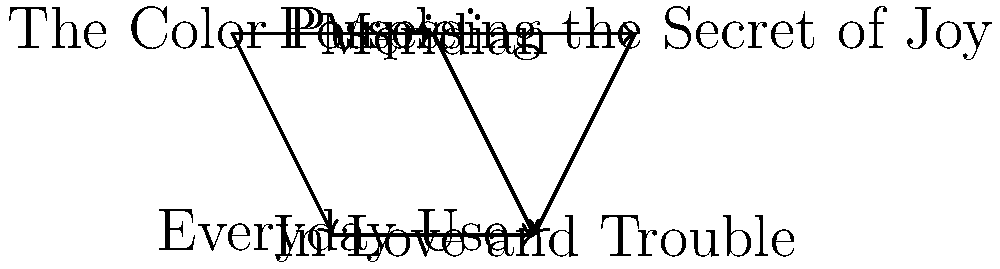In the directed graph representing the flow of themes across Alice Walker's works, which book appears to be the most influential, serving as a source for multiple other works? To determine the most influential book in Alice Walker's works based on the given directed graph, we need to follow these steps:

1. Identify the nodes (books) in the graph:
   - The Color Purple
   - Meridian
   - Possessing the Secret of Joy
   - Everyday Use
   - In Love and Trouble

2. Count the number of outgoing arrows (edges) for each node:
   - The Color Purple: 2 outgoing arrows
   - Meridian: 2 outgoing arrows
   - Possessing the Secret of Joy: 1 outgoing arrow
   - Everyday Use: 1 outgoing arrow
   - In Love and Trouble: 0 outgoing arrows

3. Analyze the connections:
   - The Color Purple influences Meridian and Everyday Use
   - Meridian influences Possessing the Secret of Joy and In Love and Trouble
   - Possessing the Secret of Joy influences In Love and Trouble
   - Everyday Use influences In Love and Trouble

4. Identify the book with the most outgoing connections:
   Both The Color Purple and Meridian have 2 outgoing arrows, which is the highest number in the graph.

5. Consider the overall influence:
   The Color Purple appears at the beginning of the thematic flow, directly influencing Meridian, which in turn influences two other works. This suggests that The Color Purple has both direct and indirect influence on multiple works.

Based on this analysis, The Color Purple appears to be the most influential book, serving as a source for multiple other works both directly and indirectly.
Answer: The Color Purple 